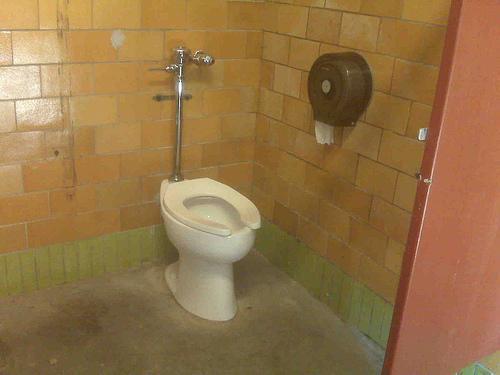How many toilets are there?
Give a very brief answer. 1. 